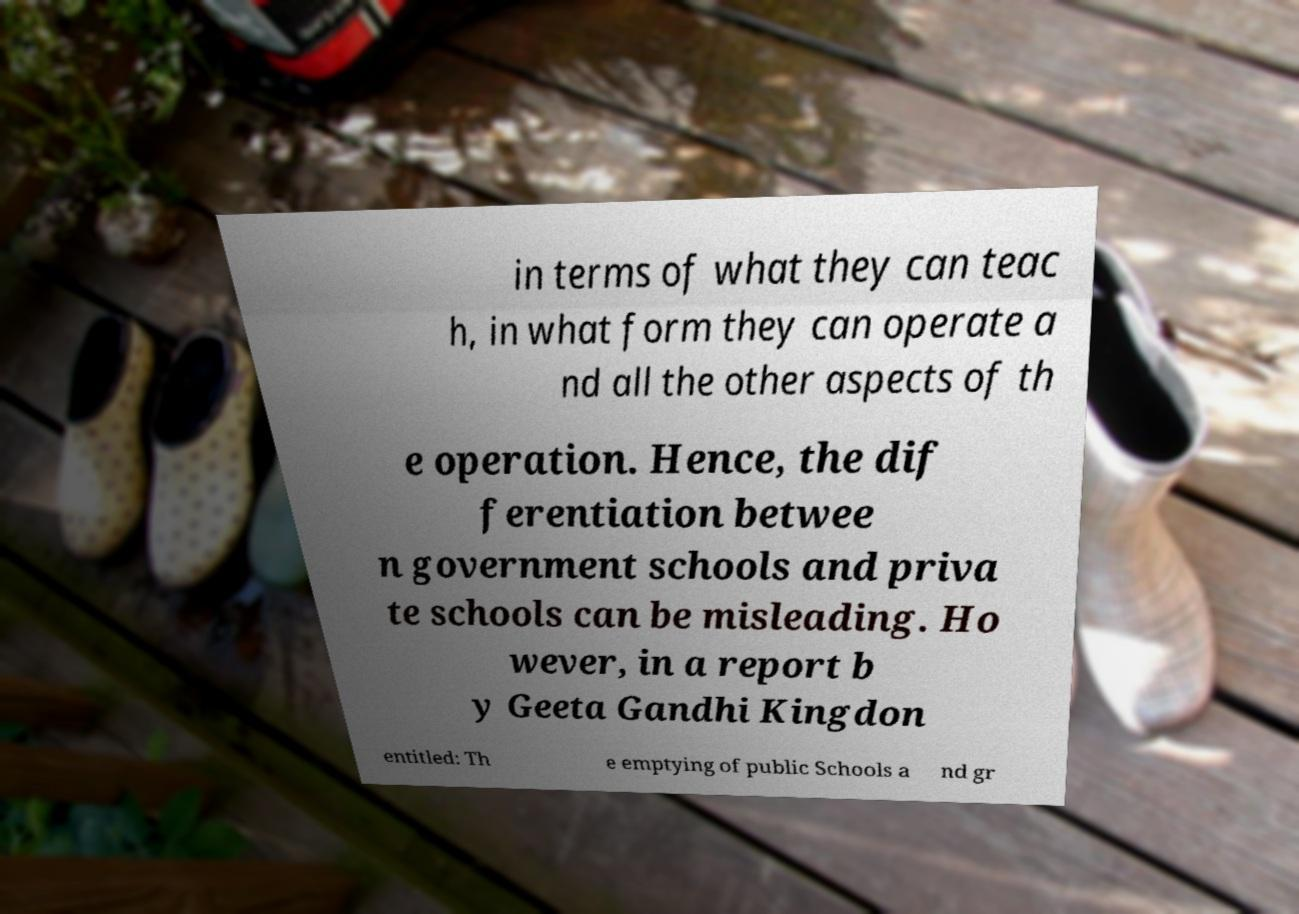I need the written content from this picture converted into text. Can you do that? in terms of what they can teac h, in what form they can operate a nd all the other aspects of th e operation. Hence, the dif ferentiation betwee n government schools and priva te schools can be misleading. Ho wever, in a report b y Geeta Gandhi Kingdon entitled: Th e emptying of public Schools a nd gr 